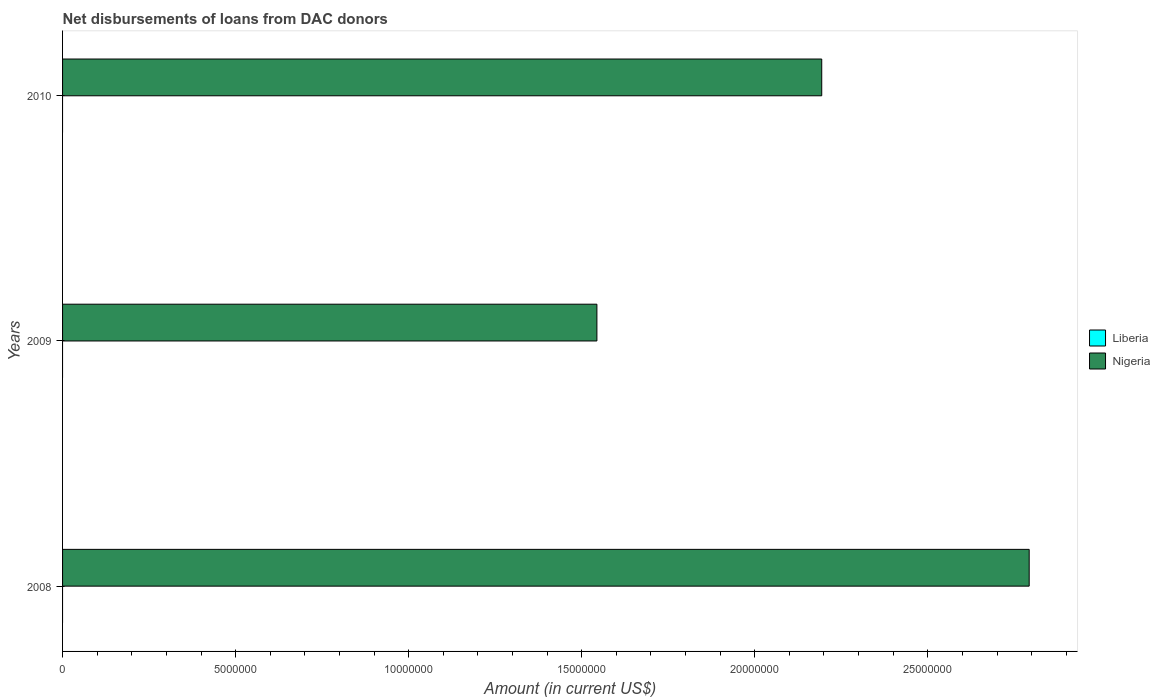How many different coloured bars are there?
Ensure brevity in your answer.  1. Are the number of bars on each tick of the Y-axis equal?
Offer a terse response. Yes. How many bars are there on the 3rd tick from the bottom?
Provide a short and direct response. 1. In how many cases, is the number of bars for a given year not equal to the number of legend labels?
Keep it short and to the point. 3. Across all years, what is the maximum amount of loans disbursed in Nigeria?
Ensure brevity in your answer.  2.79e+07. In which year was the amount of loans disbursed in Nigeria maximum?
Offer a very short reply. 2008. What is the total amount of loans disbursed in Nigeria in the graph?
Give a very brief answer. 6.53e+07. What is the difference between the amount of loans disbursed in Nigeria in 2008 and that in 2009?
Provide a succinct answer. 1.25e+07. What is the difference between the amount of loans disbursed in Nigeria in 2010 and the amount of loans disbursed in Liberia in 2009?
Ensure brevity in your answer.  2.19e+07. In how many years, is the amount of loans disbursed in Nigeria greater than 23000000 US$?
Offer a terse response. 1. What is the ratio of the amount of loans disbursed in Nigeria in 2009 to that in 2010?
Your answer should be very brief. 0.7. What is the difference between the highest and the second highest amount of loans disbursed in Nigeria?
Ensure brevity in your answer.  5.99e+06. What is the difference between the highest and the lowest amount of loans disbursed in Nigeria?
Offer a very short reply. 1.25e+07. How many bars are there?
Offer a very short reply. 3. Are all the bars in the graph horizontal?
Ensure brevity in your answer.  Yes. How many years are there in the graph?
Offer a terse response. 3. What is the difference between two consecutive major ticks on the X-axis?
Provide a short and direct response. 5.00e+06. Does the graph contain any zero values?
Offer a very short reply. Yes. Does the graph contain grids?
Provide a short and direct response. No. Where does the legend appear in the graph?
Provide a short and direct response. Center right. How are the legend labels stacked?
Make the answer very short. Vertical. What is the title of the graph?
Your answer should be compact. Net disbursements of loans from DAC donors. Does "Botswana" appear as one of the legend labels in the graph?
Your response must be concise. No. What is the Amount (in current US$) in Nigeria in 2008?
Provide a short and direct response. 2.79e+07. What is the Amount (in current US$) of Liberia in 2009?
Keep it short and to the point. 0. What is the Amount (in current US$) in Nigeria in 2009?
Make the answer very short. 1.54e+07. What is the Amount (in current US$) in Liberia in 2010?
Provide a succinct answer. 0. What is the Amount (in current US$) of Nigeria in 2010?
Provide a short and direct response. 2.19e+07. Across all years, what is the maximum Amount (in current US$) of Nigeria?
Provide a succinct answer. 2.79e+07. Across all years, what is the minimum Amount (in current US$) of Nigeria?
Keep it short and to the point. 1.54e+07. What is the total Amount (in current US$) of Nigeria in the graph?
Keep it short and to the point. 6.53e+07. What is the difference between the Amount (in current US$) in Nigeria in 2008 and that in 2009?
Ensure brevity in your answer.  1.25e+07. What is the difference between the Amount (in current US$) in Nigeria in 2008 and that in 2010?
Provide a short and direct response. 5.99e+06. What is the difference between the Amount (in current US$) of Nigeria in 2009 and that in 2010?
Ensure brevity in your answer.  -6.50e+06. What is the average Amount (in current US$) in Nigeria per year?
Offer a terse response. 2.18e+07. What is the ratio of the Amount (in current US$) of Nigeria in 2008 to that in 2009?
Ensure brevity in your answer.  1.81. What is the ratio of the Amount (in current US$) of Nigeria in 2008 to that in 2010?
Your response must be concise. 1.27. What is the ratio of the Amount (in current US$) of Nigeria in 2009 to that in 2010?
Provide a short and direct response. 0.7. What is the difference between the highest and the second highest Amount (in current US$) of Nigeria?
Ensure brevity in your answer.  5.99e+06. What is the difference between the highest and the lowest Amount (in current US$) in Nigeria?
Give a very brief answer. 1.25e+07. 